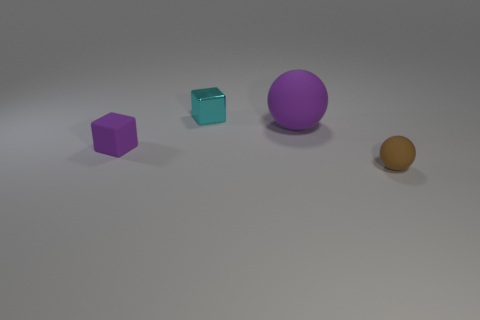Add 3 tiny blue metallic cubes. How many objects exist? 7 Subtract all big yellow shiny cylinders. Subtract all big purple spheres. How many objects are left? 3 Add 3 small brown balls. How many small brown balls are left? 4 Add 4 small gray matte spheres. How many small gray matte spheres exist? 4 Subtract 0 cyan cylinders. How many objects are left? 4 